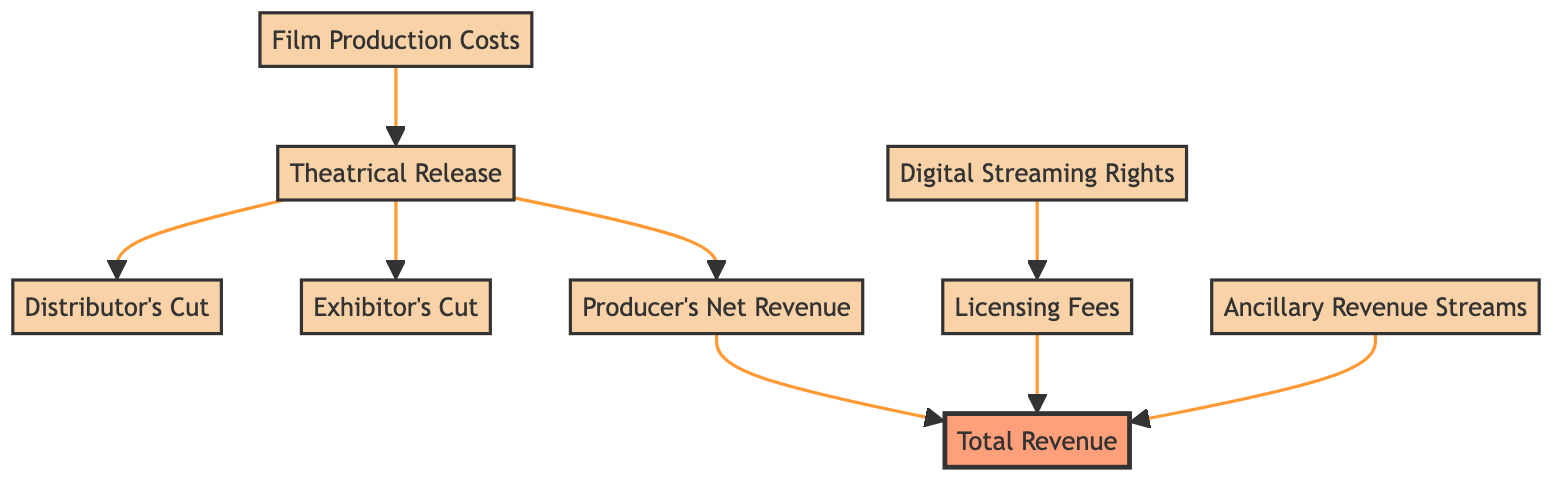What is the first node in the flow chart? The flow chart starts with the node "Film Production Costs," which represents the initial expenses incurred during filmmaking.
Answer: Film Production Costs How many nodes are there in the flow chart? Counting all distinct elements in the flow chart, there are a total of 9 nodes representing different stages and revenue sources in the monetization process.
Answer: 9 What does the "Distributor's Cut" represent? The "Distributor's Cut" represents the percentage of box office revenue taken by distribution companies before the remaining revenue goes to the producer.
Answer: Percentage of box office revenue Which nodes contribute to the "Total Revenue"? The "Total Revenue" node combines revenue from three distinct sources: "Producer's Net Revenue," "Licensing Fees," and "Ancillary Revenue Streams."
Answer: Three sources What is the relationship between "Digital Streaming Rights" and "Licensing Fees"? "Digital Streaming Rights" leads to "Licensing Fees," indicating that the sale of these rights generates revenue, which is categorized as licensing fees.
Answer: Digital Streaming Rights lead to Licensing Fees How do "Ancillary Revenue Streams" relate to "Total Revenue"? "Ancillary Revenue Streams" directly contribute to "Total Revenue," indicating they add additional financial value on top of other revenue sources.
Answer: They contribute to total revenue What is the last node in the flow chart? The last node in the flow chart is "Total Revenue," which summarizes all revenues generated from various sources throughout the film monetization process.
Answer: Total Revenue What is deducted from box office revenue to calculate "Producer's Net Revenue"? The "Producer's Net Revenue" is calculated after deducting both the "Distributor's Cut" and the "Exhibitor's Cut" from the box office revenue.
Answer: Distributor's Cut and Exhibitor's Cut Which node indicates where licensing revenue is generated? The "Licensing Fees" node indicates the revenue generated from the sale of digital streaming rights, showing its importance in the monetization process.
Answer: Licensing Fees What comes after "Theatrical Release" in the flow? After "Theatrical Release," the flow branches into three paths: "Distributor's Cut," "Exhibitor's Cut," and "Producer's Net Revenue," indicating the distribution of box office revenue.
Answer: Distributor's Cut, Exhibitor's Cut, and Producer's Net Revenue 